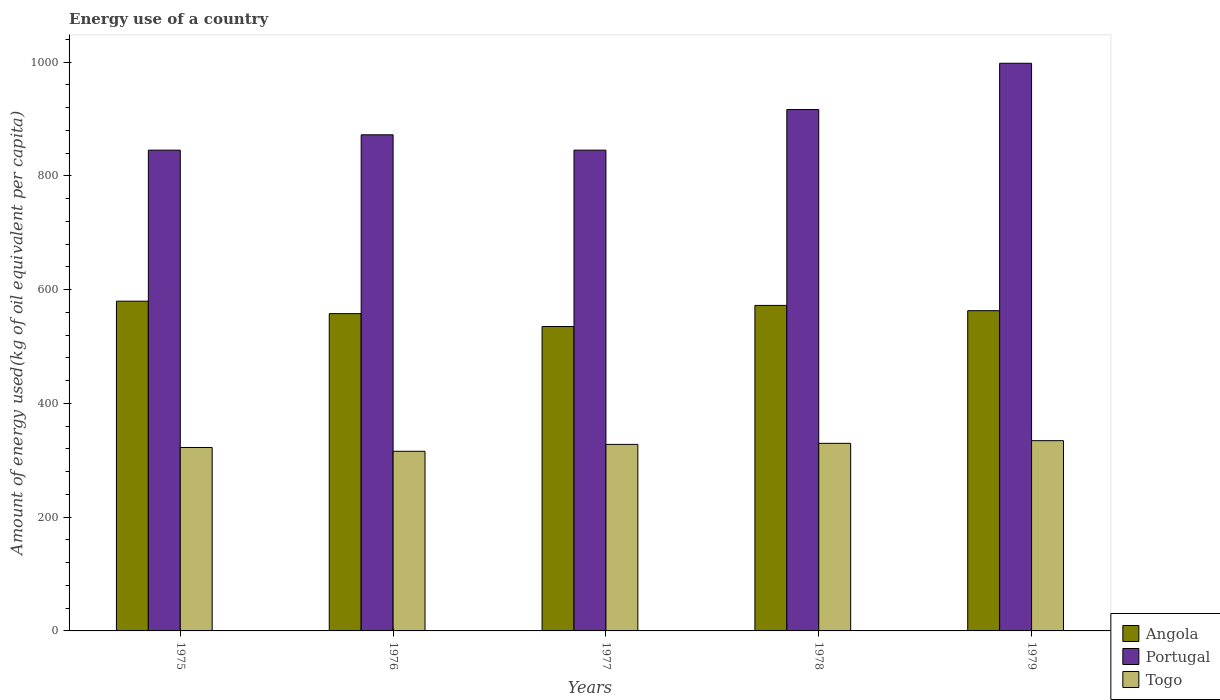How many different coloured bars are there?
Offer a terse response. 3. How many groups of bars are there?
Provide a succinct answer. 5. Are the number of bars per tick equal to the number of legend labels?
Make the answer very short. Yes. How many bars are there on the 5th tick from the left?
Offer a very short reply. 3. What is the label of the 1st group of bars from the left?
Provide a short and direct response. 1975. In how many cases, is the number of bars for a given year not equal to the number of legend labels?
Provide a succinct answer. 0. What is the amount of energy used in in Portugal in 1975?
Keep it short and to the point. 845.36. Across all years, what is the maximum amount of energy used in in Angola?
Ensure brevity in your answer.  579.81. Across all years, what is the minimum amount of energy used in in Angola?
Ensure brevity in your answer.  535.25. In which year was the amount of energy used in in Angola maximum?
Your answer should be compact. 1975. In which year was the amount of energy used in in Portugal minimum?
Give a very brief answer. 1975. What is the total amount of energy used in in Togo in the graph?
Provide a succinct answer. 1630.76. What is the difference between the amount of energy used in in Portugal in 1976 and that in 1978?
Your answer should be compact. -44.42. What is the difference between the amount of energy used in in Angola in 1977 and the amount of energy used in in Togo in 1976?
Give a very brief answer. 219.4. What is the average amount of energy used in in Angola per year?
Provide a short and direct response. 561.69. In the year 1976, what is the difference between the amount of energy used in in Togo and amount of energy used in in Angola?
Offer a very short reply. -242.07. What is the ratio of the amount of energy used in in Angola in 1977 to that in 1978?
Your response must be concise. 0.94. Is the amount of energy used in in Angola in 1977 less than that in 1979?
Ensure brevity in your answer.  Yes. What is the difference between the highest and the second highest amount of energy used in in Togo?
Your response must be concise. 4.7. What is the difference between the highest and the lowest amount of energy used in in Togo?
Give a very brief answer. 18.69. In how many years, is the amount of energy used in in Togo greater than the average amount of energy used in in Togo taken over all years?
Offer a terse response. 3. What does the 2nd bar from the left in 1979 represents?
Your answer should be very brief. Portugal. What does the 1st bar from the right in 1975 represents?
Your answer should be compact. Togo. Is it the case that in every year, the sum of the amount of energy used in in Angola and amount of energy used in in Togo is greater than the amount of energy used in in Portugal?
Offer a very short reply. No. How many bars are there?
Make the answer very short. 15. What is the difference between two consecutive major ticks on the Y-axis?
Offer a very short reply. 200. Are the values on the major ticks of Y-axis written in scientific E-notation?
Keep it short and to the point. No. Does the graph contain any zero values?
Your answer should be very brief. No. Does the graph contain grids?
Your response must be concise. No. Where does the legend appear in the graph?
Make the answer very short. Bottom right. How many legend labels are there?
Keep it short and to the point. 3. How are the legend labels stacked?
Your answer should be very brief. Vertical. What is the title of the graph?
Offer a very short reply. Energy use of a country. Does "Panama" appear as one of the legend labels in the graph?
Provide a succinct answer. No. What is the label or title of the Y-axis?
Provide a succinct answer. Amount of energy used(kg of oil equivalent per capita). What is the Amount of energy used(kg of oil equivalent per capita) in Angola in 1975?
Provide a short and direct response. 579.81. What is the Amount of energy used(kg of oil equivalent per capita) in Portugal in 1975?
Provide a short and direct response. 845.36. What is the Amount of energy used(kg of oil equivalent per capita) of Togo in 1975?
Your response must be concise. 322.52. What is the Amount of energy used(kg of oil equivalent per capita) of Angola in 1976?
Offer a very short reply. 557.92. What is the Amount of energy used(kg of oil equivalent per capita) of Portugal in 1976?
Your answer should be very brief. 872.35. What is the Amount of energy used(kg of oil equivalent per capita) of Togo in 1976?
Give a very brief answer. 315.86. What is the Amount of energy used(kg of oil equivalent per capita) of Angola in 1977?
Your answer should be very brief. 535.25. What is the Amount of energy used(kg of oil equivalent per capita) in Portugal in 1977?
Your response must be concise. 845.37. What is the Amount of energy used(kg of oil equivalent per capita) of Togo in 1977?
Offer a very short reply. 328. What is the Amount of energy used(kg of oil equivalent per capita) of Angola in 1978?
Give a very brief answer. 572.36. What is the Amount of energy used(kg of oil equivalent per capita) of Portugal in 1978?
Ensure brevity in your answer.  916.77. What is the Amount of energy used(kg of oil equivalent per capita) in Togo in 1978?
Provide a short and direct response. 329.84. What is the Amount of energy used(kg of oil equivalent per capita) of Angola in 1979?
Your response must be concise. 563.1. What is the Amount of energy used(kg of oil equivalent per capita) in Portugal in 1979?
Your response must be concise. 998.16. What is the Amount of energy used(kg of oil equivalent per capita) of Togo in 1979?
Your answer should be very brief. 334.54. Across all years, what is the maximum Amount of energy used(kg of oil equivalent per capita) in Angola?
Provide a short and direct response. 579.81. Across all years, what is the maximum Amount of energy used(kg of oil equivalent per capita) in Portugal?
Give a very brief answer. 998.16. Across all years, what is the maximum Amount of energy used(kg of oil equivalent per capita) of Togo?
Offer a terse response. 334.54. Across all years, what is the minimum Amount of energy used(kg of oil equivalent per capita) of Angola?
Offer a very short reply. 535.25. Across all years, what is the minimum Amount of energy used(kg of oil equivalent per capita) in Portugal?
Your answer should be very brief. 845.36. Across all years, what is the minimum Amount of energy used(kg of oil equivalent per capita) of Togo?
Your answer should be compact. 315.86. What is the total Amount of energy used(kg of oil equivalent per capita) in Angola in the graph?
Provide a succinct answer. 2808.44. What is the total Amount of energy used(kg of oil equivalent per capita) in Portugal in the graph?
Provide a succinct answer. 4478.01. What is the total Amount of energy used(kg of oil equivalent per capita) in Togo in the graph?
Make the answer very short. 1630.76. What is the difference between the Amount of energy used(kg of oil equivalent per capita) of Angola in 1975 and that in 1976?
Your answer should be very brief. 21.89. What is the difference between the Amount of energy used(kg of oil equivalent per capita) of Portugal in 1975 and that in 1976?
Provide a succinct answer. -26.99. What is the difference between the Amount of energy used(kg of oil equivalent per capita) in Togo in 1975 and that in 1976?
Give a very brief answer. 6.67. What is the difference between the Amount of energy used(kg of oil equivalent per capita) of Angola in 1975 and that in 1977?
Offer a terse response. 44.56. What is the difference between the Amount of energy used(kg of oil equivalent per capita) of Portugal in 1975 and that in 1977?
Your answer should be very brief. -0.01. What is the difference between the Amount of energy used(kg of oil equivalent per capita) of Togo in 1975 and that in 1977?
Your answer should be compact. -5.47. What is the difference between the Amount of energy used(kg of oil equivalent per capita) in Angola in 1975 and that in 1978?
Give a very brief answer. 7.45. What is the difference between the Amount of energy used(kg of oil equivalent per capita) in Portugal in 1975 and that in 1978?
Provide a succinct answer. -71.41. What is the difference between the Amount of energy used(kg of oil equivalent per capita) of Togo in 1975 and that in 1978?
Offer a very short reply. -7.32. What is the difference between the Amount of energy used(kg of oil equivalent per capita) in Angola in 1975 and that in 1979?
Your answer should be very brief. 16.72. What is the difference between the Amount of energy used(kg of oil equivalent per capita) of Portugal in 1975 and that in 1979?
Your answer should be very brief. -152.8. What is the difference between the Amount of energy used(kg of oil equivalent per capita) in Togo in 1975 and that in 1979?
Keep it short and to the point. -12.02. What is the difference between the Amount of energy used(kg of oil equivalent per capita) of Angola in 1976 and that in 1977?
Provide a succinct answer. 22.67. What is the difference between the Amount of energy used(kg of oil equivalent per capita) in Portugal in 1976 and that in 1977?
Make the answer very short. 26.98. What is the difference between the Amount of energy used(kg of oil equivalent per capita) of Togo in 1976 and that in 1977?
Make the answer very short. -12.14. What is the difference between the Amount of energy used(kg of oil equivalent per capita) in Angola in 1976 and that in 1978?
Offer a very short reply. -14.44. What is the difference between the Amount of energy used(kg of oil equivalent per capita) of Portugal in 1976 and that in 1978?
Your answer should be compact. -44.42. What is the difference between the Amount of energy used(kg of oil equivalent per capita) in Togo in 1976 and that in 1978?
Provide a succinct answer. -13.98. What is the difference between the Amount of energy used(kg of oil equivalent per capita) in Angola in 1976 and that in 1979?
Your response must be concise. -5.17. What is the difference between the Amount of energy used(kg of oil equivalent per capita) of Portugal in 1976 and that in 1979?
Ensure brevity in your answer.  -125.81. What is the difference between the Amount of energy used(kg of oil equivalent per capita) in Togo in 1976 and that in 1979?
Provide a short and direct response. -18.69. What is the difference between the Amount of energy used(kg of oil equivalent per capita) in Angola in 1977 and that in 1978?
Provide a short and direct response. -37.1. What is the difference between the Amount of energy used(kg of oil equivalent per capita) of Portugal in 1977 and that in 1978?
Offer a terse response. -71.4. What is the difference between the Amount of energy used(kg of oil equivalent per capita) in Togo in 1977 and that in 1978?
Your answer should be compact. -1.84. What is the difference between the Amount of energy used(kg of oil equivalent per capita) in Angola in 1977 and that in 1979?
Keep it short and to the point. -27.84. What is the difference between the Amount of energy used(kg of oil equivalent per capita) in Portugal in 1977 and that in 1979?
Provide a succinct answer. -152.79. What is the difference between the Amount of energy used(kg of oil equivalent per capita) in Togo in 1977 and that in 1979?
Give a very brief answer. -6.54. What is the difference between the Amount of energy used(kg of oil equivalent per capita) in Angola in 1978 and that in 1979?
Your response must be concise. 9.26. What is the difference between the Amount of energy used(kg of oil equivalent per capita) of Portugal in 1978 and that in 1979?
Provide a succinct answer. -81.39. What is the difference between the Amount of energy used(kg of oil equivalent per capita) of Togo in 1978 and that in 1979?
Give a very brief answer. -4.7. What is the difference between the Amount of energy used(kg of oil equivalent per capita) of Angola in 1975 and the Amount of energy used(kg of oil equivalent per capita) of Portugal in 1976?
Ensure brevity in your answer.  -292.54. What is the difference between the Amount of energy used(kg of oil equivalent per capita) in Angola in 1975 and the Amount of energy used(kg of oil equivalent per capita) in Togo in 1976?
Keep it short and to the point. 263.96. What is the difference between the Amount of energy used(kg of oil equivalent per capita) of Portugal in 1975 and the Amount of energy used(kg of oil equivalent per capita) of Togo in 1976?
Offer a very short reply. 529.51. What is the difference between the Amount of energy used(kg of oil equivalent per capita) in Angola in 1975 and the Amount of energy used(kg of oil equivalent per capita) in Portugal in 1977?
Provide a short and direct response. -265.56. What is the difference between the Amount of energy used(kg of oil equivalent per capita) of Angola in 1975 and the Amount of energy used(kg of oil equivalent per capita) of Togo in 1977?
Your answer should be very brief. 251.81. What is the difference between the Amount of energy used(kg of oil equivalent per capita) in Portugal in 1975 and the Amount of energy used(kg of oil equivalent per capita) in Togo in 1977?
Offer a very short reply. 517.36. What is the difference between the Amount of energy used(kg of oil equivalent per capita) in Angola in 1975 and the Amount of energy used(kg of oil equivalent per capita) in Portugal in 1978?
Your response must be concise. -336.96. What is the difference between the Amount of energy used(kg of oil equivalent per capita) in Angola in 1975 and the Amount of energy used(kg of oil equivalent per capita) in Togo in 1978?
Keep it short and to the point. 249.97. What is the difference between the Amount of energy used(kg of oil equivalent per capita) of Portugal in 1975 and the Amount of energy used(kg of oil equivalent per capita) of Togo in 1978?
Your answer should be very brief. 515.52. What is the difference between the Amount of energy used(kg of oil equivalent per capita) of Angola in 1975 and the Amount of energy used(kg of oil equivalent per capita) of Portugal in 1979?
Make the answer very short. -418.35. What is the difference between the Amount of energy used(kg of oil equivalent per capita) in Angola in 1975 and the Amount of energy used(kg of oil equivalent per capita) in Togo in 1979?
Give a very brief answer. 245.27. What is the difference between the Amount of energy used(kg of oil equivalent per capita) of Portugal in 1975 and the Amount of energy used(kg of oil equivalent per capita) of Togo in 1979?
Make the answer very short. 510.82. What is the difference between the Amount of energy used(kg of oil equivalent per capita) in Angola in 1976 and the Amount of energy used(kg of oil equivalent per capita) in Portugal in 1977?
Your response must be concise. -287.45. What is the difference between the Amount of energy used(kg of oil equivalent per capita) of Angola in 1976 and the Amount of energy used(kg of oil equivalent per capita) of Togo in 1977?
Provide a succinct answer. 229.92. What is the difference between the Amount of energy used(kg of oil equivalent per capita) of Portugal in 1976 and the Amount of energy used(kg of oil equivalent per capita) of Togo in 1977?
Your answer should be compact. 544.35. What is the difference between the Amount of energy used(kg of oil equivalent per capita) of Angola in 1976 and the Amount of energy used(kg of oil equivalent per capita) of Portugal in 1978?
Provide a succinct answer. -358.85. What is the difference between the Amount of energy used(kg of oil equivalent per capita) of Angola in 1976 and the Amount of energy used(kg of oil equivalent per capita) of Togo in 1978?
Ensure brevity in your answer.  228.08. What is the difference between the Amount of energy used(kg of oil equivalent per capita) in Portugal in 1976 and the Amount of energy used(kg of oil equivalent per capita) in Togo in 1978?
Your response must be concise. 542.51. What is the difference between the Amount of energy used(kg of oil equivalent per capita) in Angola in 1976 and the Amount of energy used(kg of oil equivalent per capita) in Portugal in 1979?
Provide a succinct answer. -440.24. What is the difference between the Amount of energy used(kg of oil equivalent per capita) of Angola in 1976 and the Amount of energy used(kg of oil equivalent per capita) of Togo in 1979?
Make the answer very short. 223.38. What is the difference between the Amount of energy used(kg of oil equivalent per capita) of Portugal in 1976 and the Amount of energy used(kg of oil equivalent per capita) of Togo in 1979?
Offer a terse response. 537.81. What is the difference between the Amount of energy used(kg of oil equivalent per capita) in Angola in 1977 and the Amount of energy used(kg of oil equivalent per capita) in Portugal in 1978?
Your answer should be very brief. -381.52. What is the difference between the Amount of energy used(kg of oil equivalent per capita) in Angola in 1977 and the Amount of energy used(kg of oil equivalent per capita) in Togo in 1978?
Provide a succinct answer. 205.41. What is the difference between the Amount of energy used(kg of oil equivalent per capita) in Portugal in 1977 and the Amount of energy used(kg of oil equivalent per capita) in Togo in 1978?
Provide a short and direct response. 515.53. What is the difference between the Amount of energy used(kg of oil equivalent per capita) in Angola in 1977 and the Amount of energy used(kg of oil equivalent per capita) in Portugal in 1979?
Offer a very short reply. -462.91. What is the difference between the Amount of energy used(kg of oil equivalent per capita) of Angola in 1977 and the Amount of energy used(kg of oil equivalent per capita) of Togo in 1979?
Provide a succinct answer. 200.71. What is the difference between the Amount of energy used(kg of oil equivalent per capita) of Portugal in 1977 and the Amount of energy used(kg of oil equivalent per capita) of Togo in 1979?
Your response must be concise. 510.83. What is the difference between the Amount of energy used(kg of oil equivalent per capita) of Angola in 1978 and the Amount of energy used(kg of oil equivalent per capita) of Portugal in 1979?
Your answer should be compact. -425.8. What is the difference between the Amount of energy used(kg of oil equivalent per capita) of Angola in 1978 and the Amount of energy used(kg of oil equivalent per capita) of Togo in 1979?
Offer a very short reply. 237.81. What is the difference between the Amount of energy used(kg of oil equivalent per capita) of Portugal in 1978 and the Amount of energy used(kg of oil equivalent per capita) of Togo in 1979?
Provide a short and direct response. 582.23. What is the average Amount of energy used(kg of oil equivalent per capita) of Angola per year?
Offer a terse response. 561.69. What is the average Amount of energy used(kg of oil equivalent per capita) of Portugal per year?
Keep it short and to the point. 895.6. What is the average Amount of energy used(kg of oil equivalent per capita) of Togo per year?
Your answer should be very brief. 326.15. In the year 1975, what is the difference between the Amount of energy used(kg of oil equivalent per capita) of Angola and Amount of energy used(kg of oil equivalent per capita) of Portugal?
Your response must be concise. -265.55. In the year 1975, what is the difference between the Amount of energy used(kg of oil equivalent per capita) of Angola and Amount of energy used(kg of oil equivalent per capita) of Togo?
Your answer should be very brief. 257.29. In the year 1975, what is the difference between the Amount of energy used(kg of oil equivalent per capita) of Portugal and Amount of energy used(kg of oil equivalent per capita) of Togo?
Provide a succinct answer. 522.84. In the year 1976, what is the difference between the Amount of energy used(kg of oil equivalent per capita) in Angola and Amount of energy used(kg of oil equivalent per capita) in Portugal?
Provide a succinct answer. -314.43. In the year 1976, what is the difference between the Amount of energy used(kg of oil equivalent per capita) in Angola and Amount of energy used(kg of oil equivalent per capita) in Togo?
Ensure brevity in your answer.  242.07. In the year 1976, what is the difference between the Amount of energy used(kg of oil equivalent per capita) of Portugal and Amount of energy used(kg of oil equivalent per capita) of Togo?
Give a very brief answer. 556.49. In the year 1977, what is the difference between the Amount of energy used(kg of oil equivalent per capita) of Angola and Amount of energy used(kg of oil equivalent per capita) of Portugal?
Give a very brief answer. -310.12. In the year 1977, what is the difference between the Amount of energy used(kg of oil equivalent per capita) in Angola and Amount of energy used(kg of oil equivalent per capita) in Togo?
Your response must be concise. 207.25. In the year 1977, what is the difference between the Amount of energy used(kg of oil equivalent per capita) in Portugal and Amount of energy used(kg of oil equivalent per capita) in Togo?
Make the answer very short. 517.37. In the year 1978, what is the difference between the Amount of energy used(kg of oil equivalent per capita) in Angola and Amount of energy used(kg of oil equivalent per capita) in Portugal?
Give a very brief answer. -344.41. In the year 1978, what is the difference between the Amount of energy used(kg of oil equivalent per capita) in Angola and Amount of energy used(kg of oil equivalent per capita) in Togo?
Give a very brief answer. 242.52. In the year 1978, what is the difference between the Amount of energy used(kg of oil equivalent per capita) of Portugal and Amount of energy used(kg of oil equivalent per capita) of Togo?
Offer a terse response. 586.93. In the year 1979, what is the difference between the Amount of energy used(kg of oil equivalent per capita) in Angola and Amount of energy used(kg of oil equivalent per capita) in Portugal?
Offer a very short reply. -435.06. In the year 1979, what is the difference between the Amount of energy used(kg of oil equivalent per capita) of Angola and Amount of energy used(kg of oil equivalent per capita) of Togo?
Your answer should be compact. 228.55. In the year 1979, what is the difference between the Amount of energy used(kg of oil equivalent per capita) in Portugal and Amount of energy used(kg of oil equivalent per capita) in Togo?
Give a very brief answer. 663.62. What is the ratio of the Amount of energy used(kg of oil equivalent per capita) in Angola in 1975 to that in 1976?
Make the answer very short. 1.04. What is the ratio of the Amount of energy used(kg of oil equivalent per capita) of Portugal in 1975 to that in 1976?
Your response must be concise. 0.97. What is the ratio of the Amount of energy used(kg of oil equivalent per capita) in Togo in 1975 to that in 1976?
Your answer should be very brief. 1.02. What is the ratio of the Amount of energy used(kg of oil equivalent per capita) in Angola in 1975 to that in 1977?
Your answer should be very brief. 1.08. What is the ratio of the Amount of energy used(kg of oil equivalent per capita) of Togo in 1975 to that in 1977?
Keep it short and to the point. 0.98. What is the ratio of the Amount of energy used(kg of oil equivalent per capita) in Portugal in 1975 to that in 1978?
Keep it short and to the point. 0.92. What is the ratio of the Amount of energy used(kg of oil equivalent per capita) of Togo in 1975 to that in 1978?
Provide a succinct answer. 0.98. What is the ratio of the Amount of energy used(kg of oil equivalent per capita) in Angola in 1975 to that in 1979?
Your answer should be compact. 1.03. What is the ratio of the Amount of energy used(kg of oil equivalent per capita) in Portugal in 1975 to that in 1979?
Ensure brevity in your answer.  0.85. What is the ratio of the Amount of energy used(kg of oil equivalent per capita) in Togo in 1975 to that in 1979?
Your answer should be compact. 0.96. What is the ratio of the Amount of energy used(kg of oil equivalent per capita) of Angola in 1976 to that in 1977?
Your response must be concise. 1.04. What is the ratio of the Amount of energy used(kg of oil equivalent per capita) in Portugal in 1976 to that in 1977?
Ensure brevity in your answer.  1.03. What is the ratio of the Amount of energy used(kg of oil equivalent per capita) in Togo in 1976 to that in 1977?
Provide a succinct answer. 0.96. What is the ratio of the Amount of energy used(kg of oil equivalent per capita) in Angola in 1976 to that in 1978?
Make the answer very short. 0.97. What is the ratio of the Amount of energy used(kg of oil equivalent per capita) in Portugal in 1976 to that in 1978?
Provide a succinct answer. 0.95. What is the ratio of the Amount of energy used(kg of oil equivalent per capita) in Togo in 1976 to that in 1978?
Your answer should be very brief. 0.96. What is the ratio of the Amount of energy used(kg of oil equivalent per capita) of Angola in 1976 to that in 1979?
Your response must be concise. 0.99. What is the ratio of the Amount of energy used(kg of oil equivalent per capita) of Portugal in 1976 to that in 1979?
Your answer should be compact. 0.87. What is the ratio of the Amount of energy used(kg of oil equivalent per capita) in Togo in 1976 to that in 1979?
Provide a short and direct response. 0.94. What is the ratio of the Amount of energy used(kg of oil equivalent per capita) in Angola in 1977 to that in 1978?
Keep it short and to the point. 0.94. What is the ratio of the Amount of energy used(kg of oil equivalent per capita) in Portugal in 1977 to that in 1978?
Provide a succinct answer. 0.92. What is the ratio of the Amount of energy used(kg of oil equivalent per capita) in Angola in 1977 to that in 1979?
Keep it short and to the point. 0.95. What is the ratio of the Amount of energy used(kg of oil equivalent per capita) of Portugal in 1977 to that in 1979?
Your answer should be very brief. 0.85. What is the ratio of the Amount of energy used(kg of oil equivalent per capita) of Togo in 1977 to that in 1979?
Your answer should be compact. 0.98. What is the ratio of the Amount of energy used(kg of oil equivalent per capita) of Angola in 1978 to that in 1979?
Your response must be concise. 1.02. What is the ratio of the Amount of energy used(kg of oil equivalent per capita) of Portugal in 1978 to that in 1979?
Offer a very short reply. 0.92. What is the ratio of the Amount of energy used(kg of oil equivalent per capita) in Togo in 1978 to that in 1979?
Provide a succinct answer. 0.99. What is the difference between the highest and the second highest Amount of energy used(kg of oil equivalent per capita) in Angola?
Provide a short and direct response. 7.45. What is the difference between the highest and the second highest Amount of energy used(kg of oil equivalent per capita) in Portugal?
Give a very brief answer. 81.39. What is the difference between the highest and the second highest Amount of energy used(kg of oil equivalent per capita) in Togo?
Offer a terse response. 4.7. What is the difference between the highest and the lowest Amount of energy used(kg of oil equivalent per capita) in Angola?
Your response must be concise. 44.56. What is the difference between the highest and the lowest Amount of energy used(kg of oil equivalent per capita) of Portugal?
Your answer should be very brief. 152.8. What is the difference between the highest and the lowest Amount of energy used(kg of oil equivalent per capita) in Togo?
Ensure brevity in your answer.  18.69. 